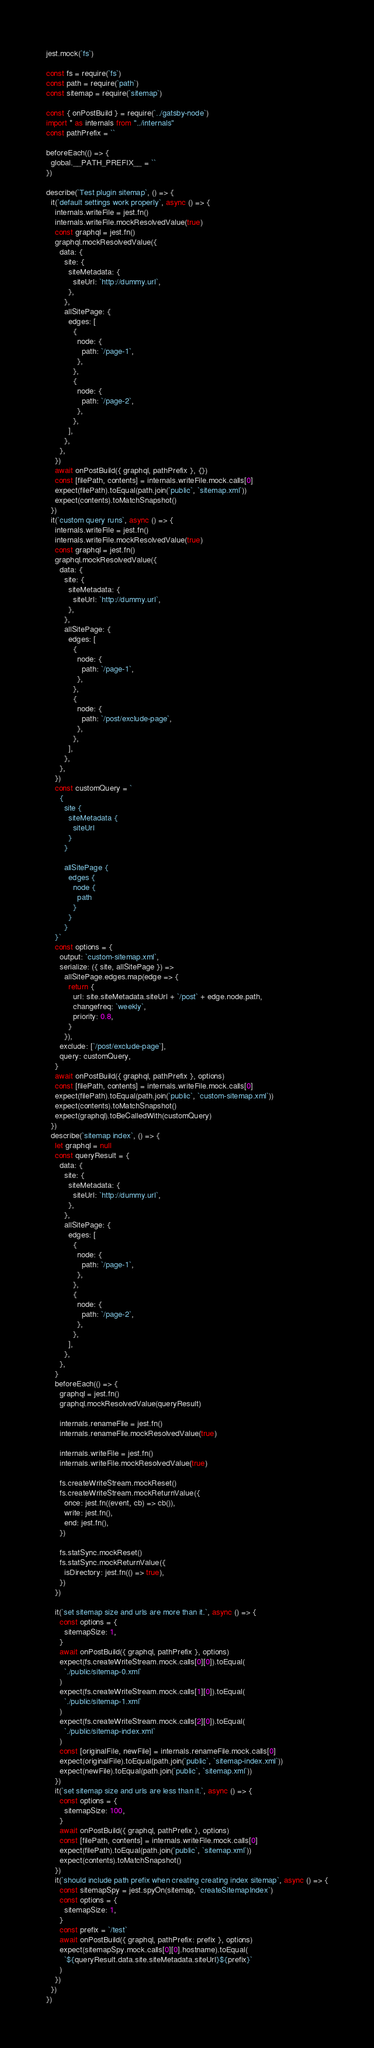Convert code to text. <code><loc_0><loc_0><loc_500><loc_500><_JavaScript_>jest.mock(`fs`)

const fs = require(`fs`)
const path = require(`path`)
const sitemap = require(`sitemap`)

const { onPostBuild } = require(`../gatsby-node`)
import * as internals from "../internals"
const pathPrefix = ``

beforeEach(() => {
  global.__PATH_PREFIX__ = ``
})

describe(`Test plugin sitemap`, () => {
  it(`default settings work properly`, async () => {
    internals.writeFile = jest.fn()
    internals.writeFile.mockResolvedValue(true)
    const graphql = jest.fn()
    graphql.mockResolvedValue({
      data: {
        site: {
          siteMetadata: {
            siteUrl: `http://dummy.url`,
          },
        },
        allSitePage: {
          edges: [
            {
              node: {
                path: `/page-1`,
              },
            },
            {
              node: {
                path: `/page-2`,
              },
            },
          ],
        },
      },
    })
    await onPostBuild({ graphql, pathPrefix }, {})
    const [filePath, contents] = internals.writeFile.mock.calls[0]
    expect(filePath).toEqual(path.join(`public`, `sitemap.xml`))
    expect(contents).toMatchSnapshot()
  })
  it(`custom query runs`, async () => {
    internals.writeFile = jest.fn()
    internals.writeFile.mockResolvedValue(true)
    const graphql = jest.fn()
    graphql.mockResolvedValue({
      data: {
        site: {
          siteMetadata: {
            siteUrl: `http://dummy.url`,
          },
        },
        allSitePage: {
          edges: [
            {
              node: {
                path: `/page-1`,
              },
            },
            {
              node: {
                path: `/post/exclude-page`,
              },
            },
          ],
        },
      },
    })
    const customQuery = `
      {
        site {
          siteMetadata {
            siteUrl
          }
        }

        allSitePage {
          edges {
            node {
              path
            }
          }
        } 
    }`
    const options = {
      output: `custom-sitemap.xml`,
      serialize: ({ site, allSitePage }) =>
        allSitePage.edges.map(edge => {
          return {
            url: site.siteMetadata.siteUrl + `/post` + edge.node.path,
            changefreq: `weekly`,
            priority: 0.8,
          }
        }),
      exclude: [`/post/exclude-page`],
      query: customQuery,
    }
    await onPostBuild({ graphql, pathPrefix }, options)
    const [filePath, contents] = internals.writeFile.mock.calls[0]
    expect(filePath).toEqual(path.join(`public`, `custom-sitemap.xml`))
    expect(contents).toMatchSnapshot()
    expect(graphql).toBeCalledWith(customQuery)
  })
  describe(`sitemap index`, () => {
    let graphql = null
    const queryResult = {
      data: {
        site: {
          siteMetadata: {
            siteUrl: `http://dummy.url`,
          },
        },
        allSitePage: {
          edges: [
            {
              node: {
                path: `/page-1`,
              },
            },
            {
              node: {
                path: `/page-2`,
              },
            },
          ],
        },
      },
    }
    beforeEach(() => {
      graphql = jest.fn()
      graphql.mockResolvedValue(queryResult)

      internals.renameFile = jest.fn()
      internals.renameFile.mockResolvedValue(true)

      internals.writeFile = jest.fn()
      internals.writeFile.mockResolvedValue(true)

      fs.createWriteStream.mockReset()
      fs.createWriteStream.mockReturnValue({
        once: jest.fn((event, cb) => cb()),
        write: jest.fn(),
        end: jest.fn(),
      })

      fs.statSync.mockReset()
      fs.statSync.mockReturnValue({
        isDirectory: jest.fn(() => true),
      })
    })

    it(`set sitemap size and urls are more than it.`, async () => {
      const options = {
        sitemapSize: 1,
      }
      await onPostBuild({ graphql, pathPrefix }, options)
      expect(fs.createWriteStream.mock.calls[0][0]).toEqual(
        `./public/sitemap-0.xml`
      )
      expect(fs.createWriteStream.mock.calls[1][0]).toEqual(
        `./public/sitemap-1.xml`
      )
      expect(fs.createWriteStream.mock.calls[2][0]).toEqual(
        `./public/sitemap-index.xml`
      )
      const [originalFile, newFile] = internals.renameFile.mock.calls[0]
      expect(originalFile).toEqual(path.join(`public`, `sitemap-index.xml`))
      expect(newFile).toEqual(path.join(`public`, `sitemap.xml`))
    })
    it(`set sitemap size and urls are less than it.`, async () => {
      const options = {
        sitemapSize: 100,
      }
      await onPostBuild({ graphql, pathPrefix }, options)
      const [filePath, contents] = internals.writeFile.mock.calls[0]
      expect(filePath).toEqual(path.join(`public`, `sitemap.xml`))
      expect(contents).toMatchSnapshot()
    })
    it(`should include path prefix when creating creating index sitemap`, async () => {
      const sitemapSpy = jest.spyOn(sitemap, `createSitemapIndex`)
      const options = {
        sitemapSize: 1,
      }
      const prefix = `/test`
      await onPostBuild({ graphql, pathPrefix: prefix }, options)
      expect(sitemapSpy.mock.calls[0][0].hostname).toEqual(
        `${queryResult.data.site.siteMetadata.siteUrl}${prefix}`
      )
    })
  })
})
</code> 